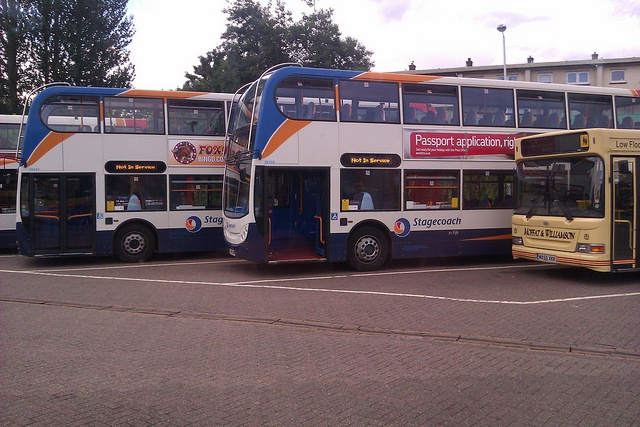Describe the objects in this image and their specific colors. I can see bus in gray, black, purple, and darkgray tones, bus in gray, black, darkgray, and navy tones, bus in gray, black, tan, and maroon tones, bus in gray, black, darkgray, and maroon tones, and people in gray and purple tones in this image. 